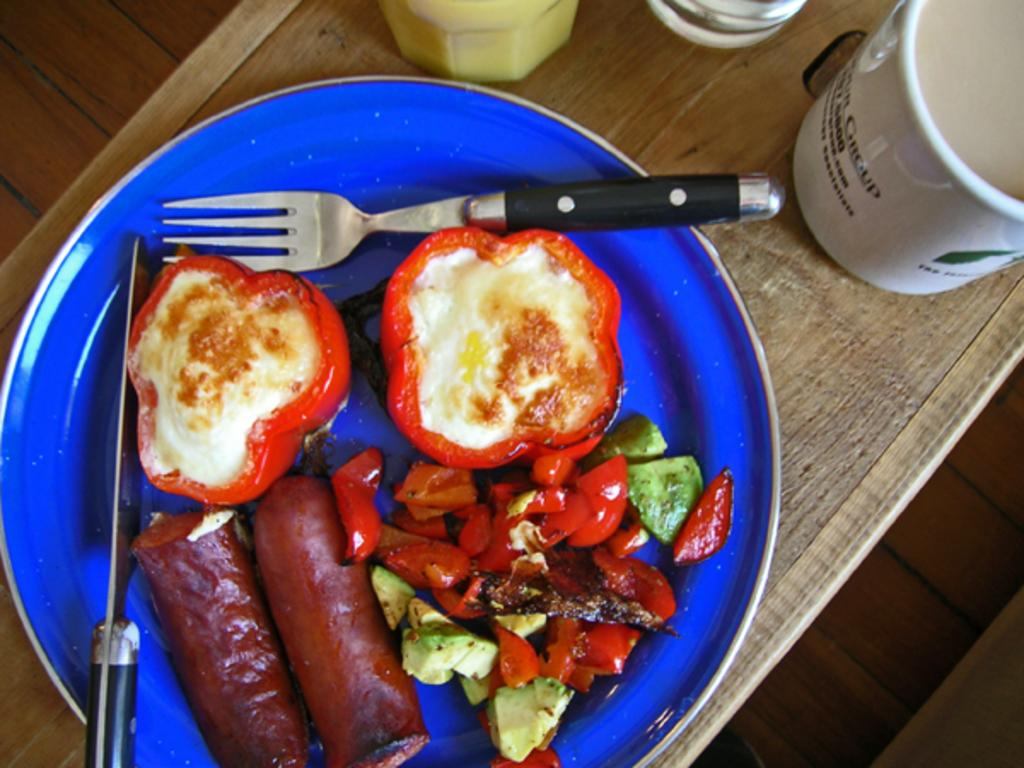What is present on the table in the image? There is a plate and a cup on the table in the image. What is on the plate? There is food on the plate, and there is also a knife and a fork on the plate. What can be used for drinking in the image? There is a cup in the image that can be used for drinking. What type of argument is taking place in the image? There is no argument present in the image; it only shows a plate, a cup, and objects on the table. How many oranges are visible in the image? There are no oranges present in the image. 